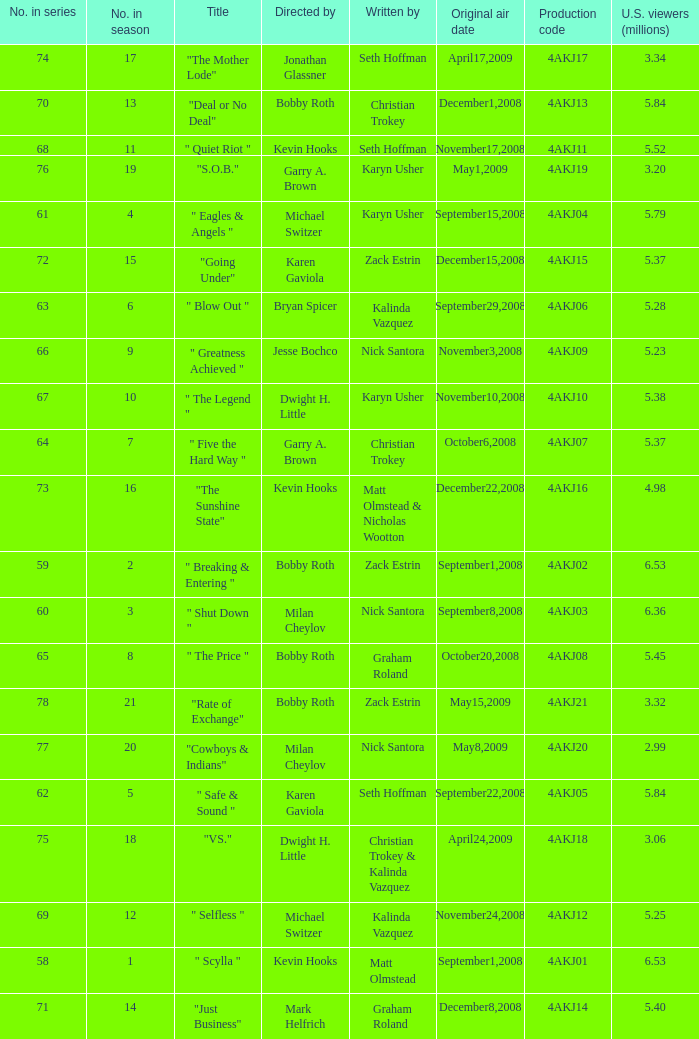Who directed the episode with production code 4akj08? Bobby Roth. 